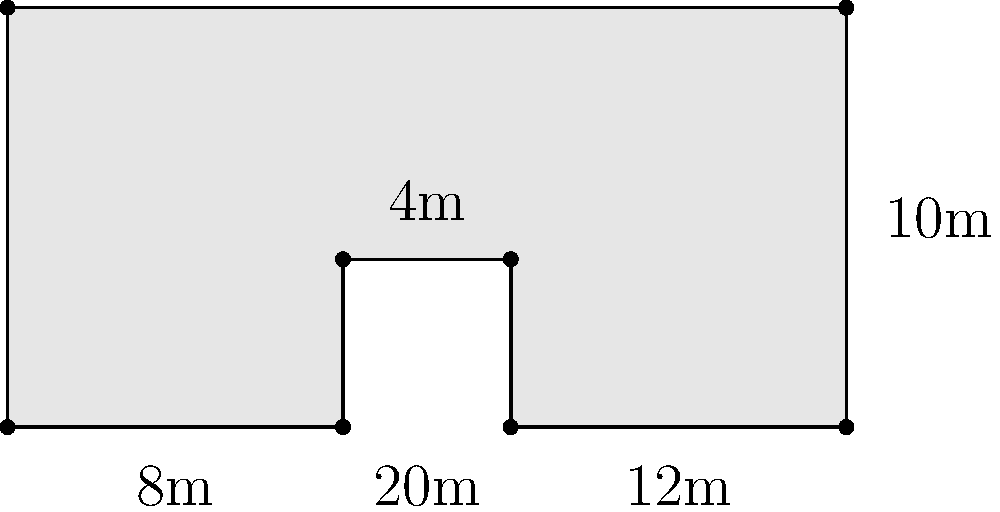For your upcoming concert, you've designed a unique stage layout as shown in the diagram. The stage has a rectangular base of 20m by 10m with a 4m by 4m section cut out from the top-right corner. Calculate the total area of this custom-shaped stage in square meters. To calculate the area of this custom-shaped stage, we can follow these steps:

1. Calculate the area of the full rectangle:
   $A_{full} = 20\text{m} \times 10\text{m} = 200\text{m}^2$

2. Calculate the area of the cut-out section:
   $A_{cutout} = 4\text{m} \times 4\text{m} = 16\text{m}^2$

3. Subtract the cut-out area from the full rectangle area:
   $A_{stage} = A_{full} - A_{cutout}$
   $A_{stage} = 200\text{m}^2 - 16\text{m}^2 = 184\text{m}^2$

Therefore, the total area of the custom-shaped stage is 184 square meters.
Answer: $184\text{m}^2$ 